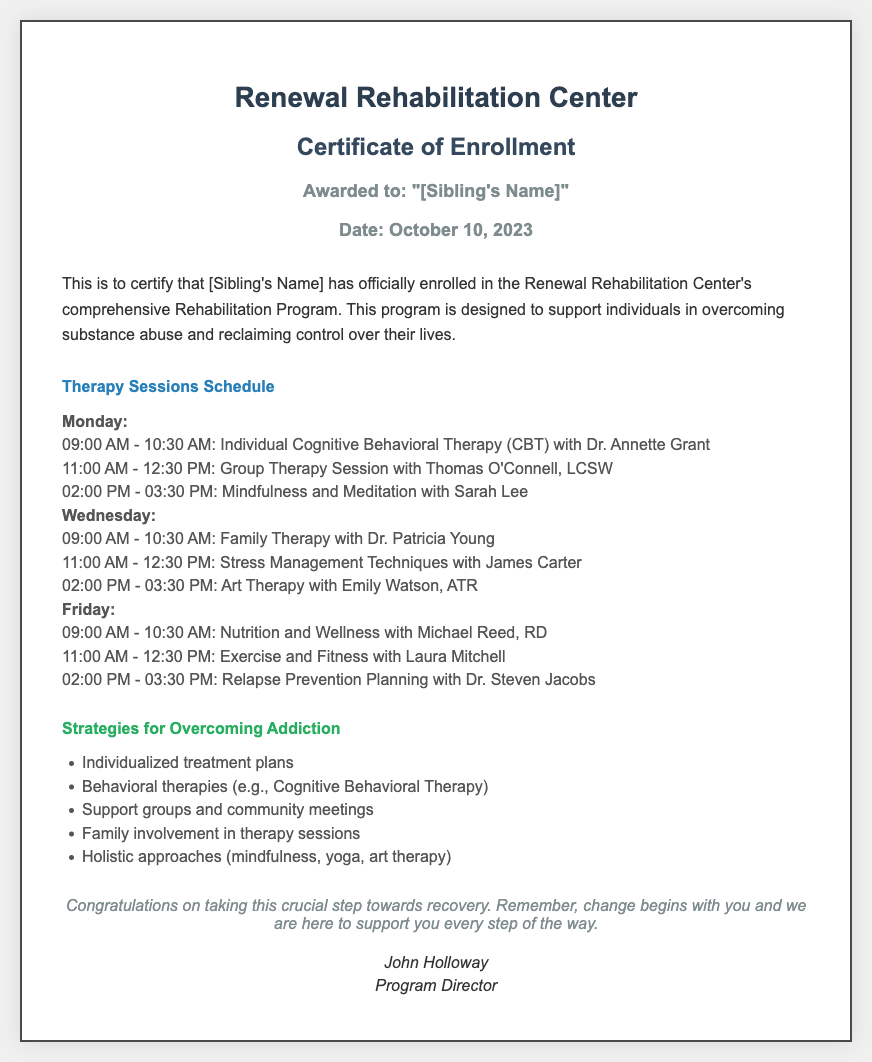What is the name of the rehabilitation center? The name of the rehabilitation center is mentioned in the header of the document.
Answer: Renewal Rehabilitation Center Who awarded the certificate? The awarding authority of the certificate is stated at the bottom of the document.
Answer: John Holloway What date was the enrollment certificate issued? The date of issuance is explicitly stated in the document.
Answer: October 10, 2023 What type of therapy is scheduled on Monday at 09:00 AM? The specific therapy type can be found in the therapy session schedule for Monday.
Answer: Individual Cognitive Behavioral Therapy How many therapy sessions are there on Friday? The count of therapy sessions can be derived from the schedule section listing them for Friday.
Answer: Three Which therapy involves family participation? The relevant therapy that includes family involvement is stated in the schedule section.
Answer: Family Therapy What is one strategy mentioned for overcoming addiction? The strategies for overcoming addiction can be found in the corresponding section of the document.
Answer: Individualized treatment plans When does the Art Therapy session take place? The time for the Art Therapy session is listed in the schedule for Wednesday.
Answer: 02:00 PM - 03:30 PM What is the focus of the session with Dr. Steven Jacobs? The focus of Dr. Steven Jacobs' session is detailed in the schedule for Friday.
Answer: Relapse Prevention Planning 